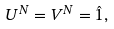<formula> <loc_0><loc_0><loc_500><loc_500>U ^ { N } = V ^ { N } = \hat { 1 } ,</formula> 